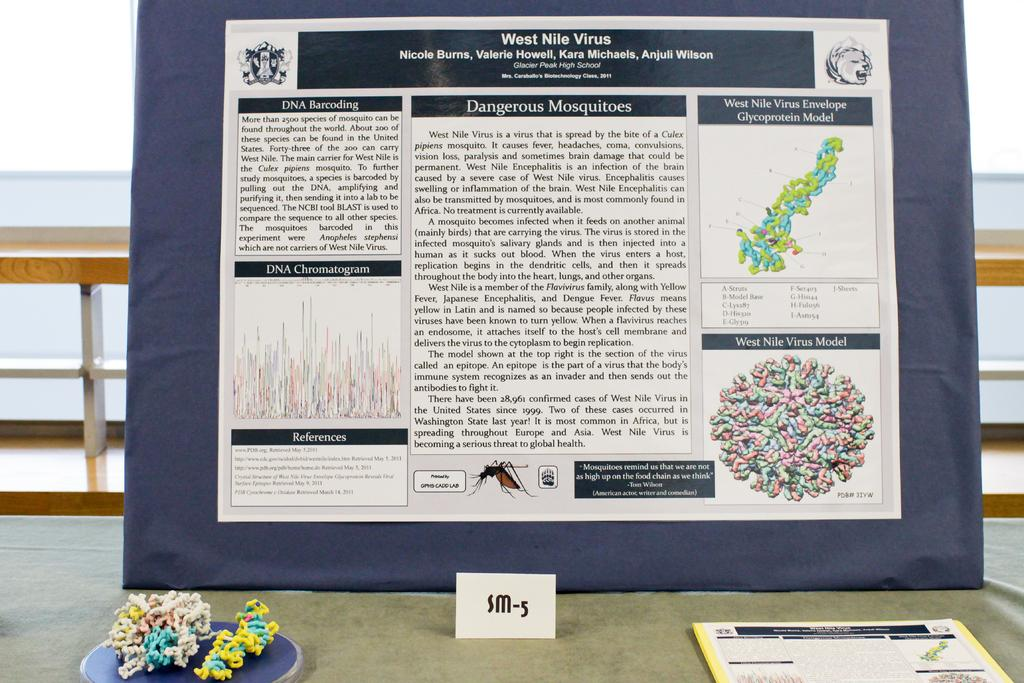<image>
Describe the image concisely. A research poster titled West Nile Virus by Nicole burns et al. is on the table outside leaning against some railing. 